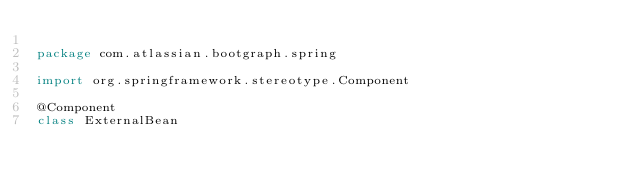<code> <loc_0><loc_0><loc_500><loc_500><_Kotlin_>
package com.atlassian.bootgraph.spring

import org.springframework.stereotype.Component

@Component
class ExternalBean</code> 